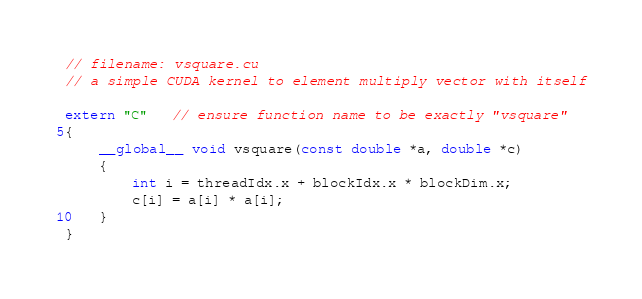Convert code to text. <code><loc_0><loc_0><loc_500><loc_500><_Cuda_>// filename: vsquare.cu
// a simple CUDA kernel to element multiply vector with itself

extern "C"   // ensure function name to be exactly "vsquare"
{
    __global__ void vsquare(const double *a, double *c)
    {
        int i = threadIdx.x + blockIdx.x * blockDim.x;
        c[i] = a[i] * a[i];
    }
}</code> 